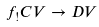<formula> <loc_0><loc_0><loc_500><loc_500>f _ { ! } C V \to D V</formula> 